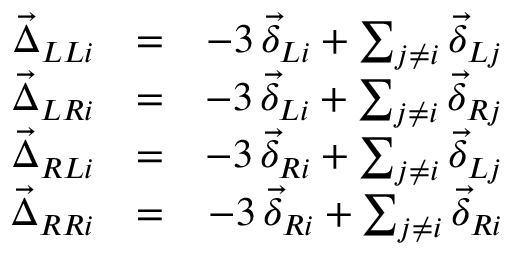Convert formula to latex. <formula><loc_0><loc_0><loc_500><loc_500>\begin{array} { r l r } { \vec { \Delta } _ { L L i } } & { = } & { - 3 \, \vec { \delta } _ { L i } + \sum _ { j \neq i } \vec { \delta } _ { L j } } \\ { \vec { \Delta } _ { L R i } } & { = } & { - 3 \, \vec { \delta } _ { L i } + \sum _ { j \neq i } \vec { \delta } _ { R j } } \\ { \vec { \Delta } _ { R L i } } & { = } & { - 3 \, \vec { \delta } _ { R i } + \sum _ { j \neq i } \vec { \delta } _ { L j } } \\ { \vec { \Delta } _ { R R i } } & { = } & { - 3 \, \vec { \delta } _ { R i } + \sum _ { j \neq i } \vec { \delta } _ { R i } } \end{array}</formula> 